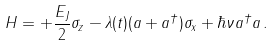<formula> <loc_0><loc_0><loc_500><loc_500>H = + \frac { E _ { J } } { 2 } \sigma _ { z } - \lambda ( t ) ( a + a ^ { \dag } ) \sigma _ { x } + \hbar { \nu } a ^ { \dag } a \, .</formula> 